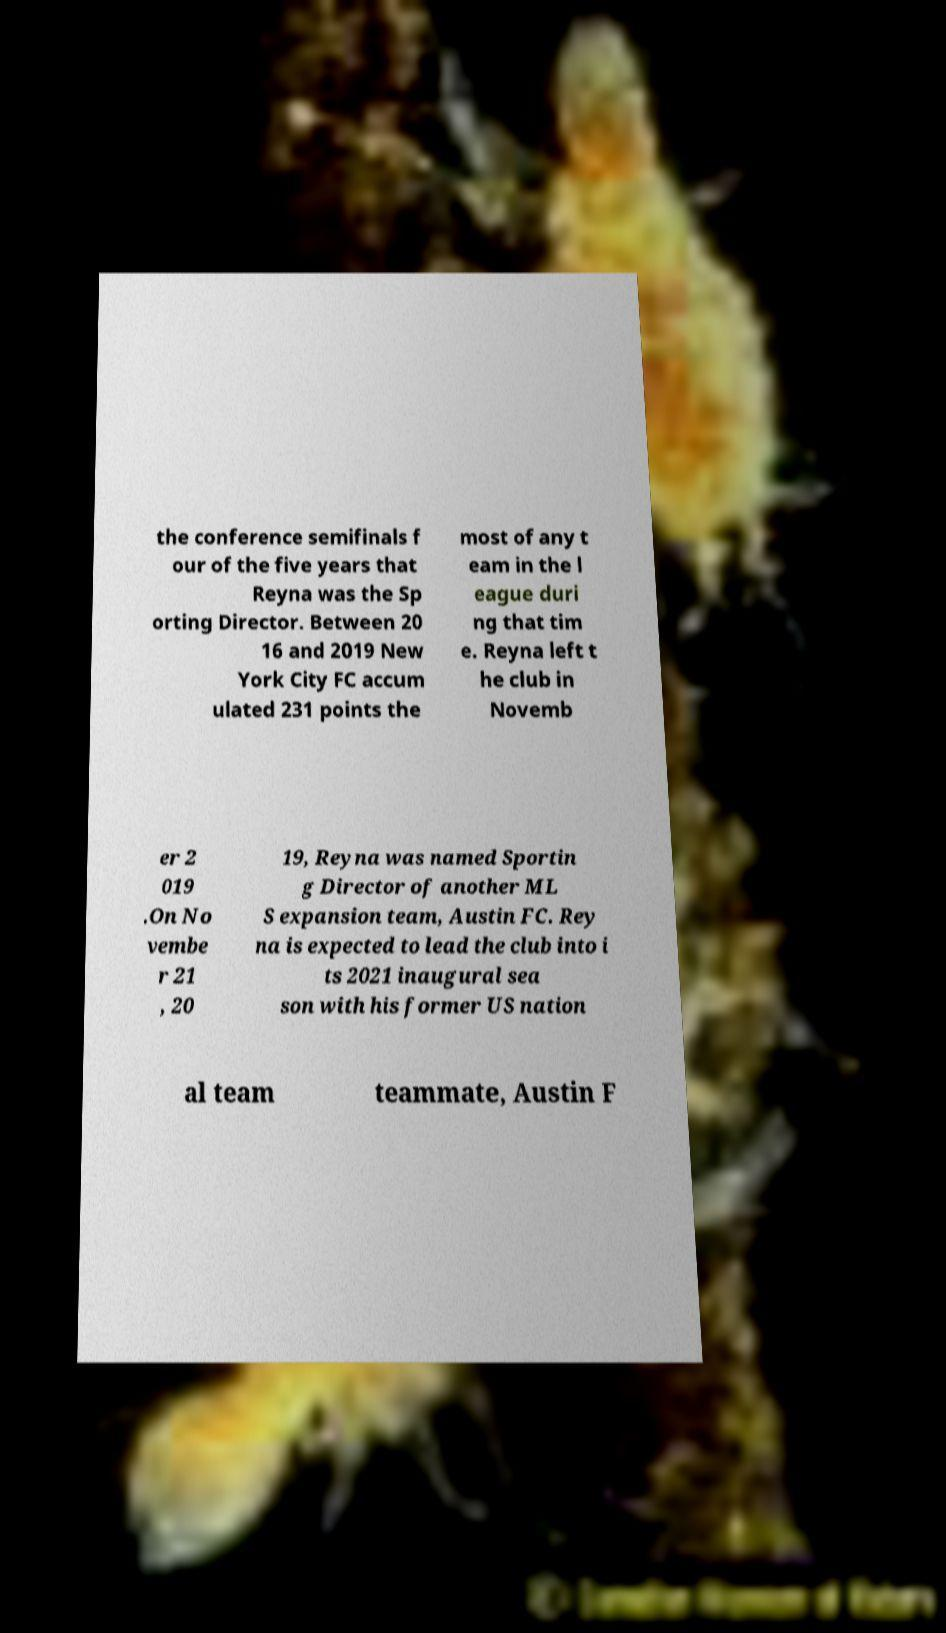What messages or text are displayed in this image? I need them in a readable, typed format. the conference semifinals f our of the five years that Reyna was the Sp orting Director. Between 20 16 and 2019 New York City FC accum ulated 231 points the most of any t eam in the l eague duri ng that tim e. Reyna left t he club in Novemb er 2 019 .On No vembe r 21 , 20 19, Reyna was named Sportin g Director of another ML S expansion team, Austin FC. Rey na is expected to lead the club into i ts 2021 inaugural sea son with his former US nation al team teammate, Austin F 